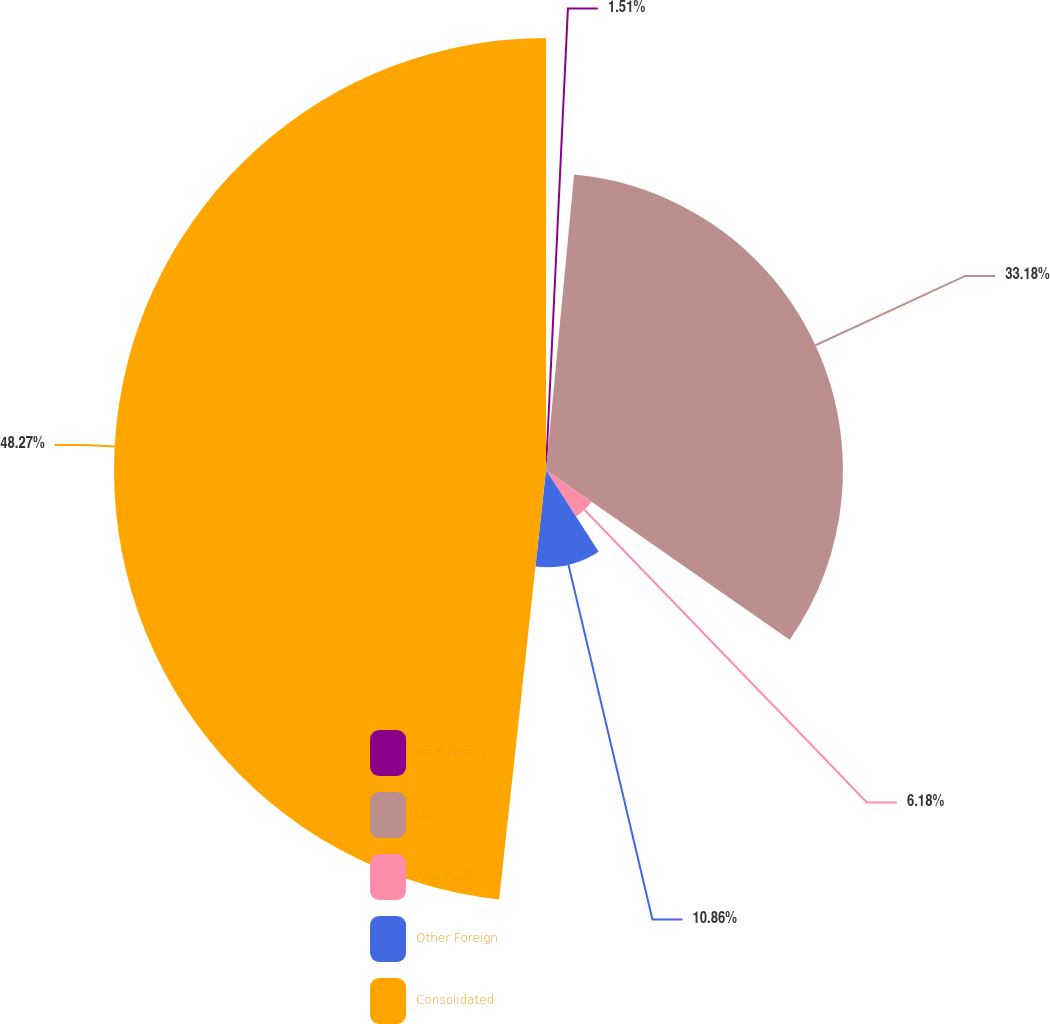Convert chart to OTSL. <chart><loc_0><loc_0><loc_500><loc_500><pie_chart><fcel>(in millions)<fcel>US<fcel>Asia Pacific<fcel>Other Foreign<fcel>Consolidated<nl><fcel>1.51%<fcel>33.18%<fcel>6.18%<fcel>10.86%<fcel>48.27%<nl></chart> 